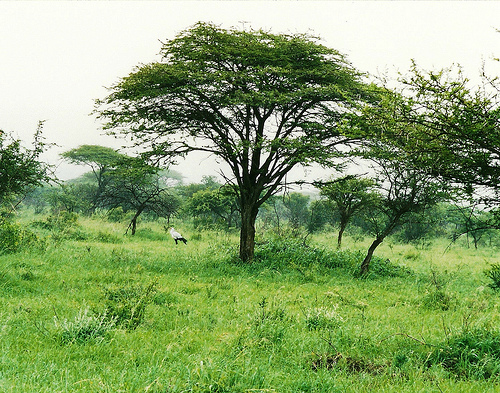<image>
Can you confirm if the tree is on the grass? Yes. Looking at the image, I can see the tree is positioned on top of the grass, with the grass providing support. 